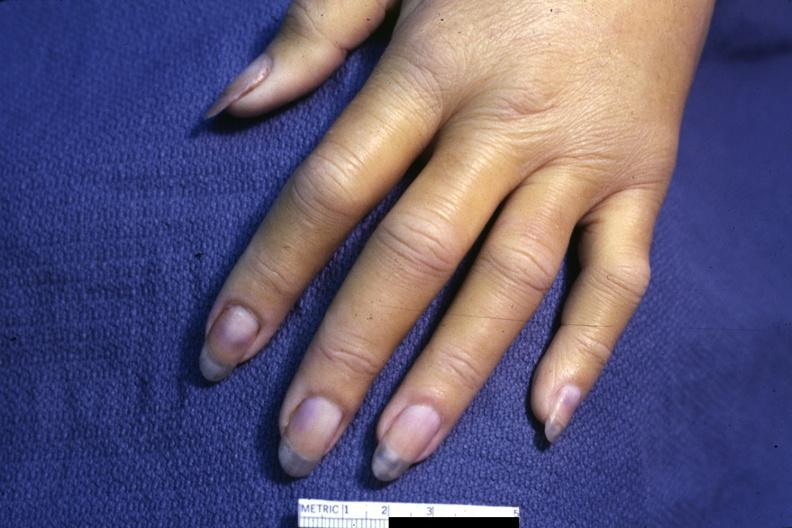what are present?
Answer the question using a single word or phrase. Extremities 